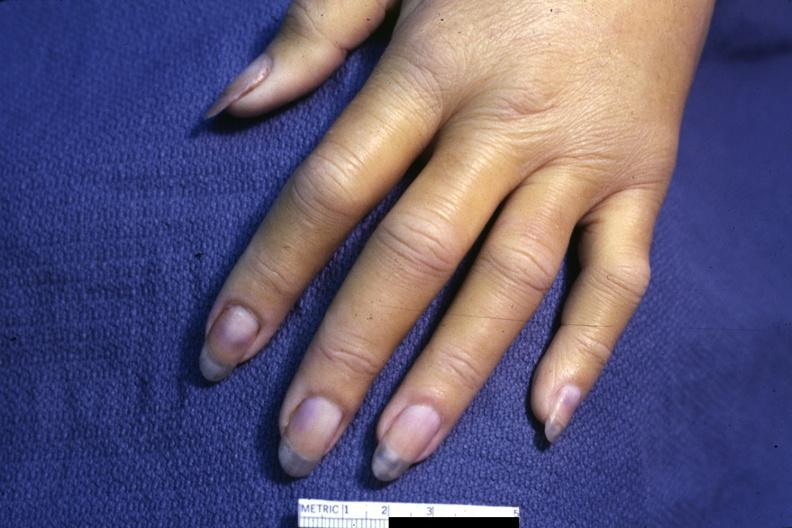what are present?
Answer the question using a single word or phrase. Extremities 